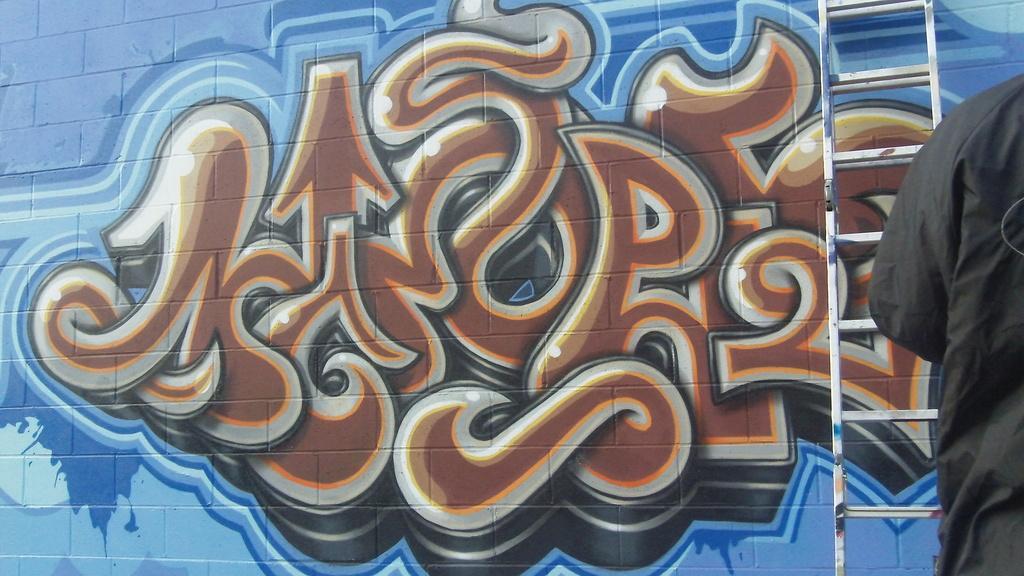Could you give a brief overview of what you see in this image? In this image, we can see an art on the wall. There is a ladder and part of a person on the right side of the image. 